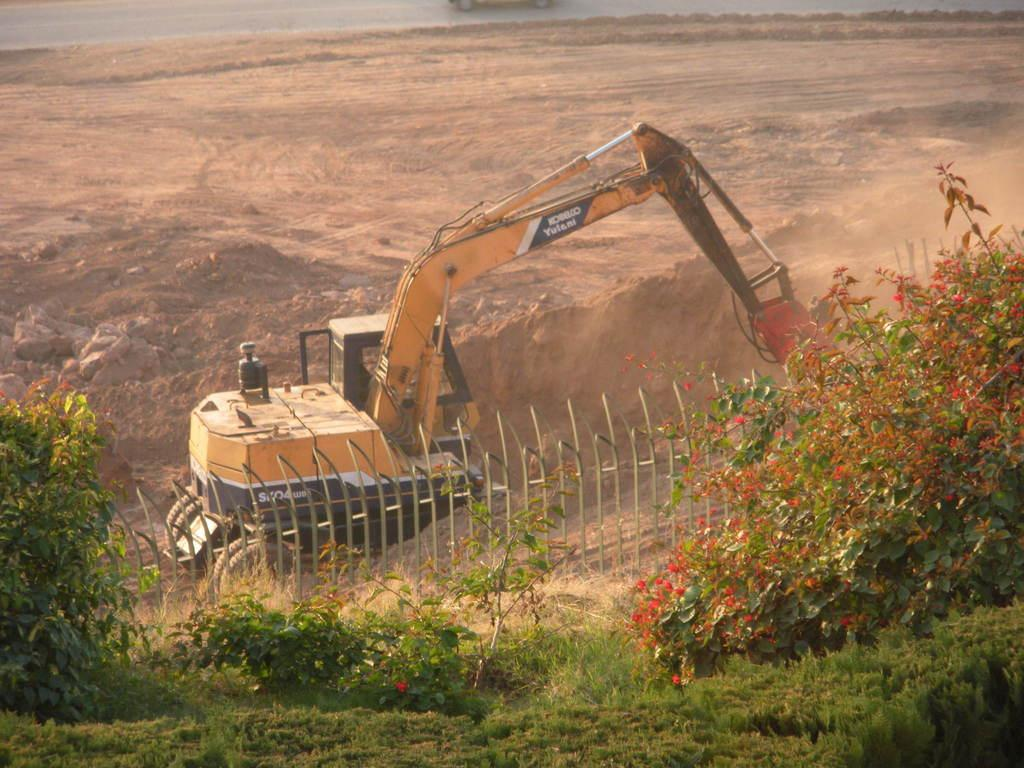What type of natural environment is visible in the foreground of the image? There is grass and plants in the foreground of the image. What is the main object in the middle of the image? There is a vehicle in the middle of the image. What type of terrain is present in the middle of the image? There is sand in the middle of the image. What type of barrier is present in the middle of the image? There is fencing in the middle of the image. What type of terrain is visible at the top of the image? There is sand visible at the top of the image. How many mice can be seen playing with a kettle in the image? There are no mice or kettle present in the image. Are the sisters in the image wearing matching outfits? There is no mention of sisters or outfits in the image, so we cannot answer this question. 